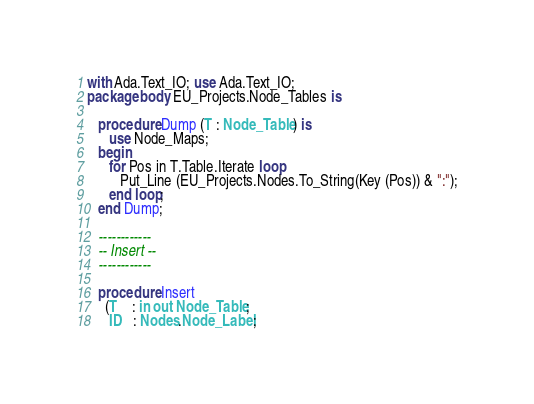Convert code to text. <code><loc_0><loc_0><loc_500><loc_500><_Ada_>with Ada.Text_IO; use Ada.Text_IO;
package body EU_Projects.Node_Tables is

   procedure Dump (T : Node_Table) is
      use Node_Maps;
   begin
      for Pos in T.Table.Iterate loop
         Put_Line (EU_Projects.Nodes.To_String(Key (Pos)) & ":");
      end loop;
   end Dump;

   ------------
   -- Insert --
   ------------

   procedure Insert
     (T    : in out Node_Table;
      ID   : Nodes.Node_Label;</code> 